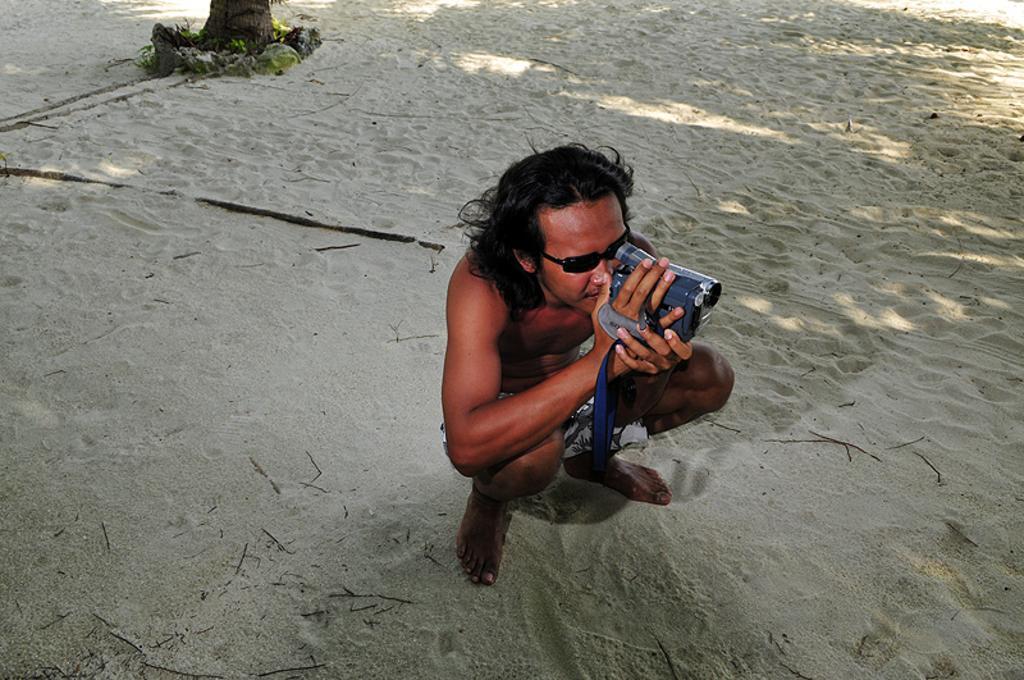In one or two sentences, can you explain what this image depicts? In this image we can see a person who is wearing sunglasses and holding a camera. We can see there is a sand. 